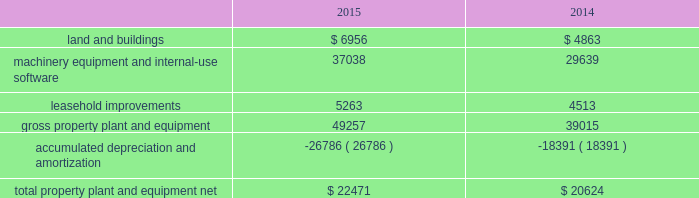Table of contents the notional amounts for outstanding derivative instruments provide one measure of the transaction volume outstanding and do not represent the amount of the company 2019s exposure to credit or market loss .
The credit risk amounts represent the company 2019s gross exposure to potential accounting loss on derivative instruments that are outstanding or unsettled if all counterparties failed to perform according to the terms of the contract , based on then-current currency or interest rates at each respective date .
The company 2019s exposure to credit loss and market risk will vary over time as currency and interest rates change .
Although the table above reflects the notional and credit risk amounts of the company 2019s derivative instruments , it does not reflect the gains or losses associated with the exposures and transactions that the instruments are intended to hedge .
The amounts ultimately realized upon settlement of these financial instruments , together with the gains and losses on the underlying exposures , will depend on actual market conditions during the remaining life of the instruments .
The company generally enters into master netting arrangements , which are designed to reduce credit risk by permitting net settlement of transactions with the same counterparty .
To further limit credit risk , the company generally enters into collateral security arrangements that provide for collateral to be received or posted when the net fair value of certain financial instruments fluctuates from contractually established thresholds .
The company presents its derivative assets and derivative liabilities at their gross fair values in its consolidated balance sheets .
The net cash collateral received by the company related to derivative instruments under its collateral security arrangements was $ 1.0 billion as of september 26 , 2015 and $ 2.1 billion as of september 27 , 2014 .
Under master netting arrangements with the respective counterparties to the company 2019s derivative contracts , the company is allowed to net settle transactions with a single net amount payable by one party to the other .
As of september 26 , 2015 and september 27 , 2014 , the potential effects of these rights of set-off associated with the company 2019s derivative contracts , including the effects of collateral , would be a reduction to both derivative assets and derivative liabilities of $ 2.2 billion and $ 1.6 billion , respectively , resulting in net derivative liabilities of $ 78 million and $ 549 million , respectively .
Accounts receivable receivables the company has considerable trade receivables outstanding with its third-party cellular network carriers , wholesalers , retailers , value-added resellers , small and mid-sized businesses and education , enterprise and government customers .
The company generally does not require collateral from its customers ; however , the company will require collateral in certain instances to limit credit risk .
In addition , when possible , the company attempts to limit credit risk on trade receivables with credit insurance for certain customers or by requiring third-party financing , loans or leases to support credit exposure .
These credit-financing arrangements are directly between the third-party financing company and the end customer .
As such , the company generally does not assume any recourse or credit risk sharing related to any of these arrangements .
As of september 26 , 2015 , the company had one customer that represented 10% ( 10 % ) or more of total trade receivables , which accounted for 12% ( 12 % ) .
As of september 27 , 2014 , the company had two customers that represented 10% ( 10 % ) or more of total trade receivables , one of which accounted for 16% ( 16 % ) and the other 13% ( 13 % ) .
The company 2019s cellular network carriers accounted for 71% ( 71 % ) and 72% ( 72 % ) of trade receivables as of september 26 , 2015 and september 27 , 2014 , respectively .
Vendor non-trade receivables the company has non-trade receivables from certain of its manufacturing vendors resulting from the sale of components to these vendors who manufacture sub-assemblies or assemble final products for the company .
The company purchases these components directly from suppliers .
Vendor non-trade receivables from three of the company 2019s vendors accounted for 38% ( 38 % ) , 18% ( 18 % ) and 14% ( 14 % ) of total vendor non-trade receivables as of september 26 , 2015 and three of the company 2019s vendors accounted for 51% ( 51 % ) , 16% ( 16 % ) and 14% ( 14 % ) of total vendor non-trade receivables as of september 27 , 2014 .
Note 3 2013 consolidated financial statement details the tables show the company 2019s consolidated financial statement details as of september 26 , 2015 and september 27 , 2014 ( in millions ) : property , plant and equipment , net .
Apple inc .
| 2015 form 10-k | 53 .
What is the percentage change in total property plant and equipment net from 2014 to 2015? 
Computations: ((22471 - 20624) / 20624)
Answer: 0.08956. 